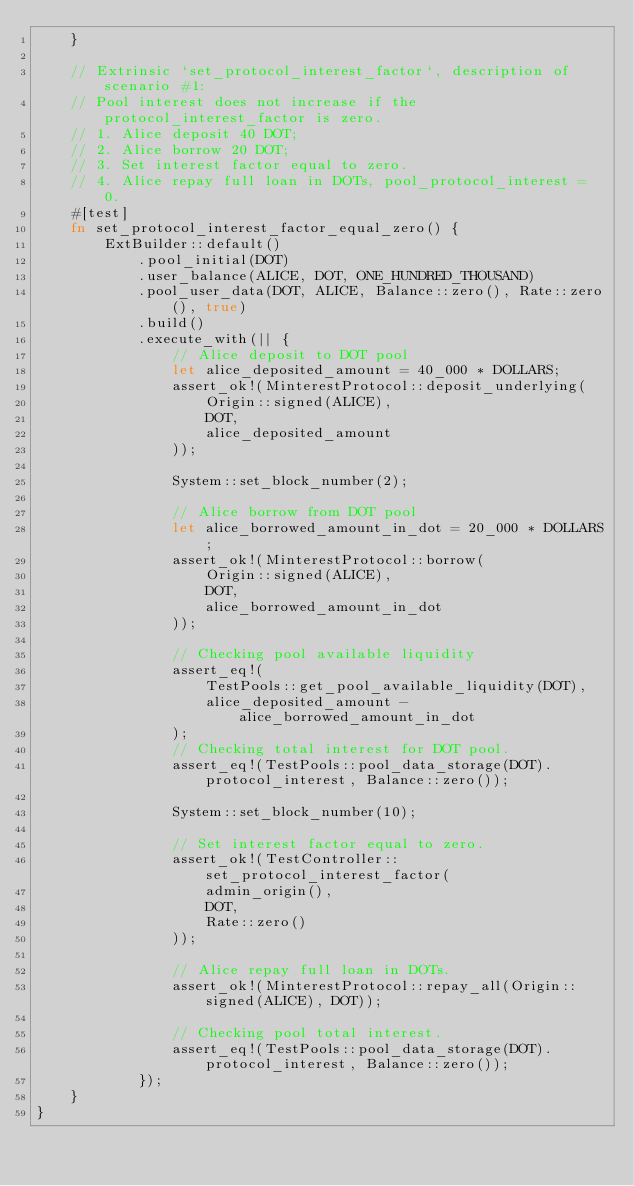<code> <loc_0><loc_0><loc_500><loc_500><_Rust_>	}

	// Extrinsic `set_protocol_interest_factor`, description of scenario #1:
	// Pool interest does not increase if the protocol_interest_factor is zero.
	// 1. Alice deposit 40 DOT;
	// 2. Alice borrow 20 DOT;
	// 3. Set interest factor equal to zero.
	// 4. Alice repay full loan in DOTs, pool_protocol_interest = 0.
	#[test]
	fn set_protocol_interest_factor_equal_zero() {
		ExtBuilder::default()
			.pool_initial(DOT)
			.user_balance(ALICE, DOT, ONE_HUNDRED_THOUSAND)
			.pool_user_data(DOT, ALICE, Balance::zero(), Rate::zero(), true)
			.build()
			.execute_with(|| {
				// Alice deposit to DOT pool
				let alice_deposited_amount = 40_000 * DOLLARS;
				assert_ok!(MinterestProtocol::deposit_underlying(
					Origin::signed(ALICE),
					DOT,
					alice_deposited_amount
				));

				System::set_block_number(2);

				// Alice borrow from DOT pool
				let alice_borrowed_amount_in_dot = 20_000 * DOLLARS;
				assert_ok!(MinterestProtocol::borrow(
					Origin::signed(ALICE),
					DOT,
					alice_borrowed_amount_in_dot
				));

				// Checking pool available liquidity
				assert_eq!(
					TestPools::get_pool_available_liquidity(DOT),
					alice_deposited_amount - alice_borrowed_amount_in_dot
				);
				// Checking total interest for DOT pool.
				assert_eq!(TestPools::pool_data_storage(DOT).protocol_interest, Balance::zero());

				System::set_block_number(10);

				// Set interest factor equal to zero.
				assert_ok!(TestController::set_protocol_interest_factor(
					admin_origin(),
					DOT,
					Rate::zero()
				));

				// Alice repay full loan in DOTs.
				assert_ok!(MinterestProtocol::repay_all(Origin::signed(ALICE), DOT));

				// Checking pool total interest.
				assert_eq!(TestPools::pool_data_storage(DOT).protocol_interest, Balance::zero());
			});
	}
}
</code> 